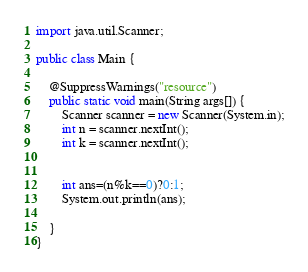<code> <loc_0><loc_0><loc_500><loc_500><_Java_>import java.util.Scanner;

public class Main {

	@SuppressWarnings("resource")
	public static void main(String args[]) {
		Scanner scanner = new Scanner(System.in);
		int n = scanner.nextInt();
		int k = scanner.nextInt();
		

		int ans=(n%k==0)?0:1;
		System.out.println(ans);

	}
}
</code> 